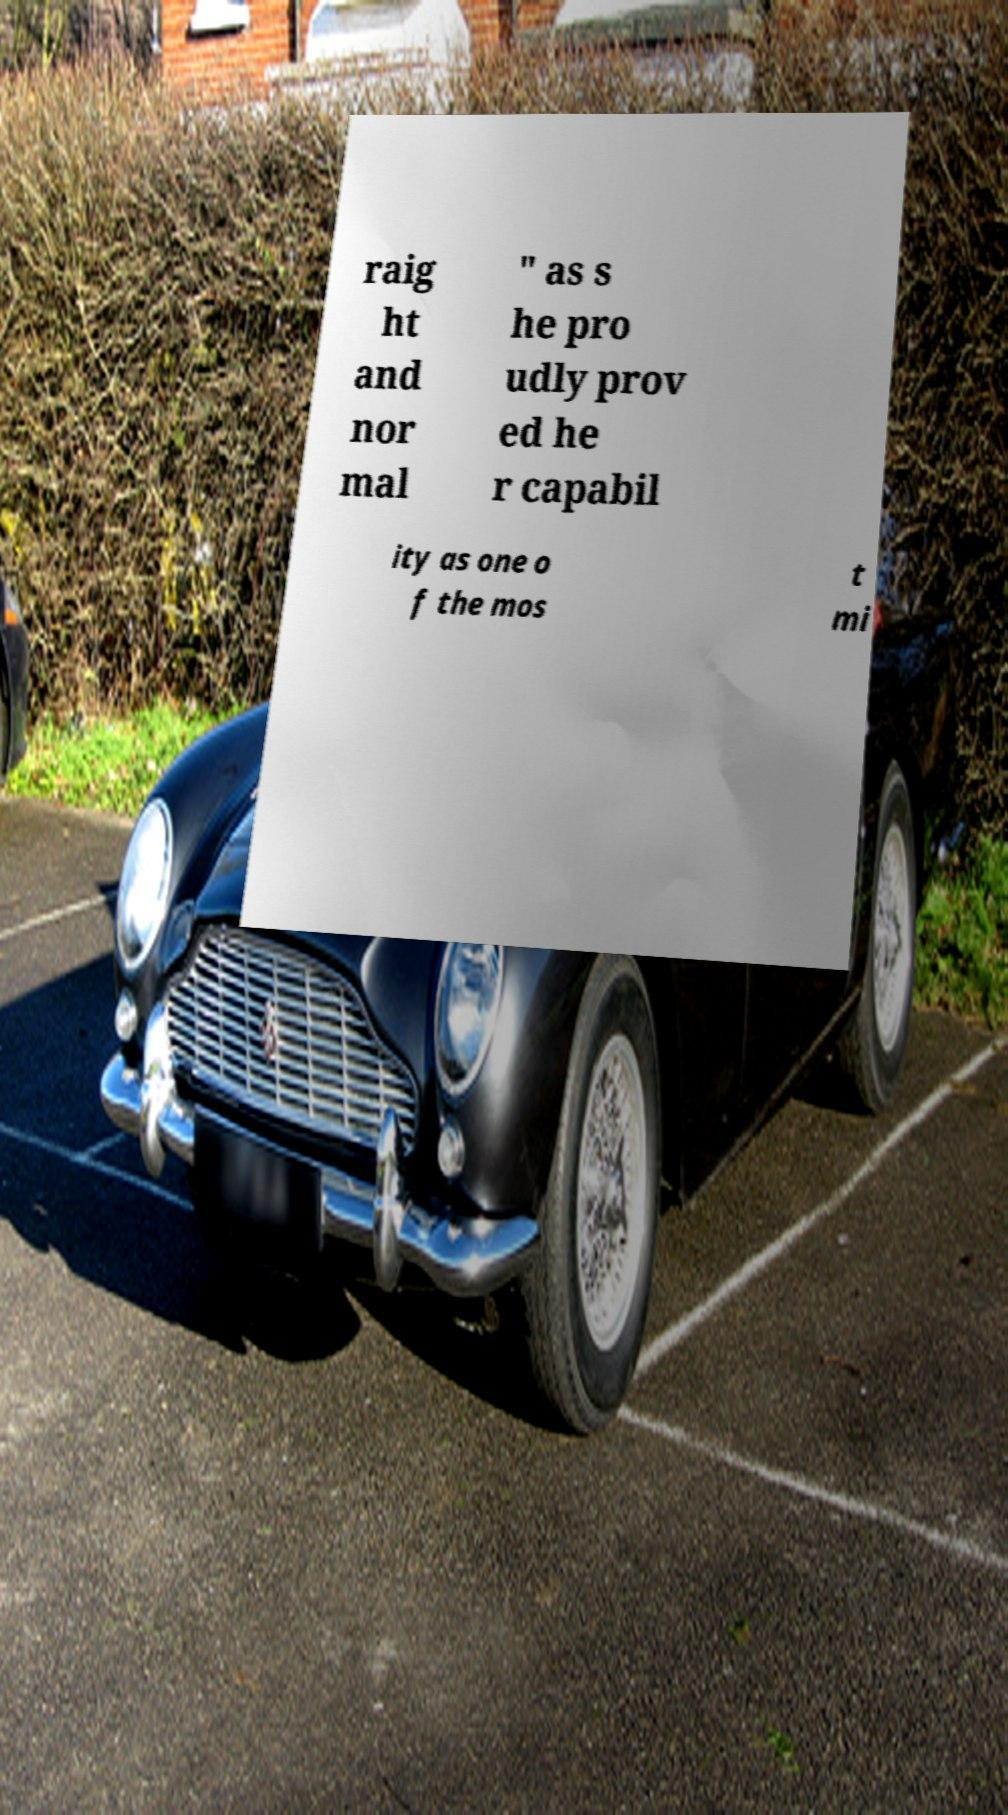Can you accurately transcribe the text from the provided image for me? raig ht and nor mal " as s he pro udly prov ed he r capabil ity as one o f the mos t mi 